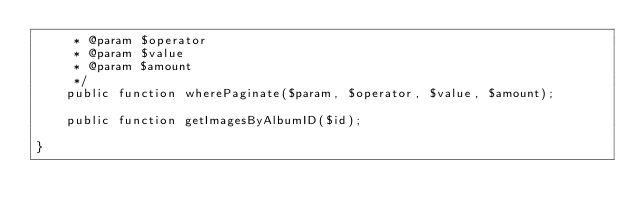Convert code to text. <code><loc_0><loc_0><loc_500><loc_500><_PHP_>     * @param $operator
     * @param $value
     * @param $amount
     */
    public function wherePaginate($param, $operator, $value, $amount);

    public function getImagesByAlbumID($id);

}
</code> 